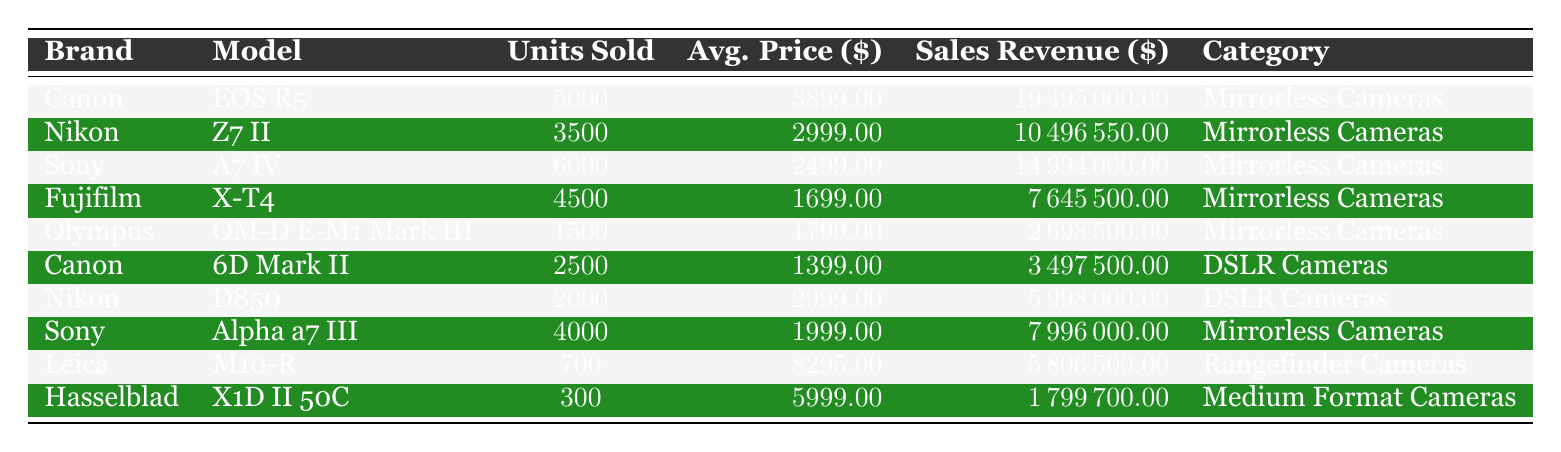What brand sold the most units in 2022? By examining the "Units Sold" column, the brand with the highest value is Sony with 6000 units sold (A7 IV model).
Answer: Sony Which camera model generated the highest sales revenue? The sales revenue values show that the Canon EOS R5 generated the highest at $19,495,000.
Answer: Canon EOS R5 What is the average price of the Nikon Z7 II? The "Average Price" for the Nikon Z7 II is $2,999.00, according to the table.
Answer: $2,999.00 How many total units were sold across all brands? By adding all units sold (5000 + 3500 + 6000 + 4500 + 1500 + 2500 + 2000 + 4000 + 700 + 300), the total is 22,500 units.
Answer: 22,500 units Did Canon have more units sold in mirrorless cameras or DSLR cameras? Canon sold 5000 units of the EOS R5 (mirrorless) and 2500 units of the 6D Mark II (DSLR), which means they sold more in mirrorless with a total of 5000 units.
Answer: Mirrorless cameras Calculate the total sales revenue for Sony's cameras. For Sony, the A7 IV generated $14,994,000 (6000 units * $2499) and the Alpha a7 III generated $7,996,000 (4000 units * $1999). The total is $14,994,000 + $7,996,000 = $22,990,000.
Answer: $22,990,000 Which brand had the lowest average price among the mirrorless cameras? Reviewing the average prices, Fujifilm's X-T4 has the lowest average price at $1,699.
Answer: Fujifilm Is the average price of the Leica M10-R higher than $8,000? The average price for the Leica M10-R is $8,295, which is above $8,000, confirming the statement to be true.
Answer: Yes What is the total sales revenue from DSLR cameras compared to mirrorless cameras? The total sales revenue for DSLR cameras is $3,497,500 (Canon 6D Mark II) + $5,998,000 (Nikon D850) = $9,495,500. For mirrorless, summing all values gives $64,858,500.
Answer: Mirrorless cameras generated more revenue Which camera had the highest average price and how much was it? The Leica M10-R had the highest average price at $8,295.
Answer: Leica M10-R, $8,295 